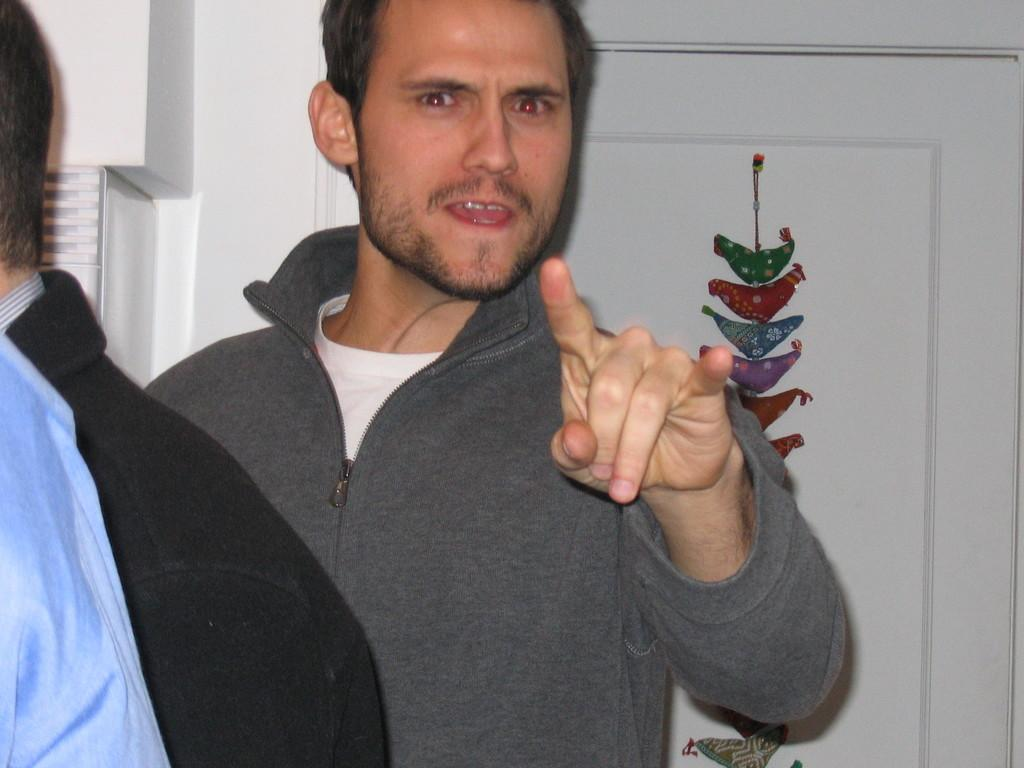How many people are in the image? There are people in the image, but the exact number is not specified. Can you describe the clothing of the man in the front? The man in the front is wearing a jacket and a white color t-shirt. What is the color of the door in the background? There is a white color door in the background of the image. What type of celery is being used to make a decision in the image? There is no celery present in the image, and no decisions are being made using celery. Is there a kite visible in the image? There is no mention of a kite in the provided facts, so it cannot be determined if one is present in the image. 